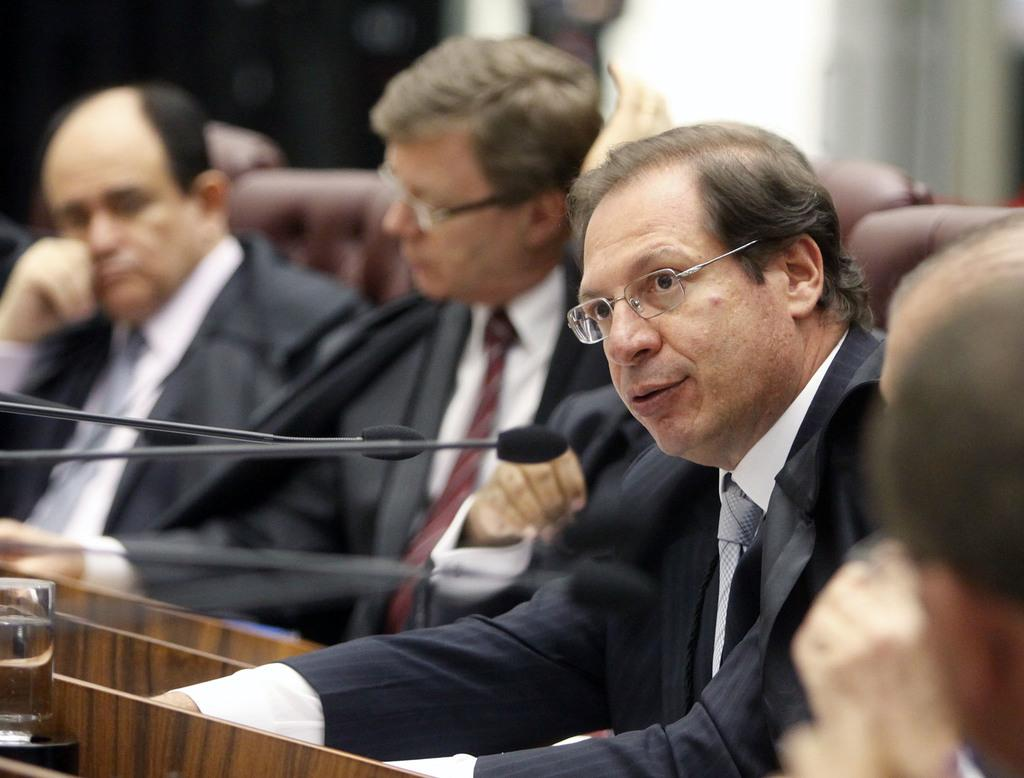What are the people in the image doing? There is a group of people sitting in the image. What objects are present that might be used for amplifying sound? There are microphones present in the image. What type of furniture or structure can be seen in the image? There are tables or podiums in the image. Can you describe the background of the image? The background of the image is blurred. What type of tools does the carpenter use in the image? There is no carpenter present in the image, so no tools can be observed. What type of verse is being recited by the people in the image? There is no indication in the image that the people are reciting any verses, so it cannot be determined from the picture. 